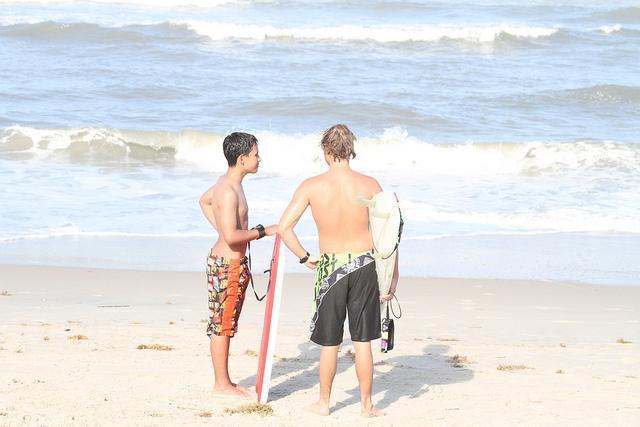How many surfboards are visible?
Give a very brief answer. 2. How many people can be seen?
Give a very brief answer. 2. 